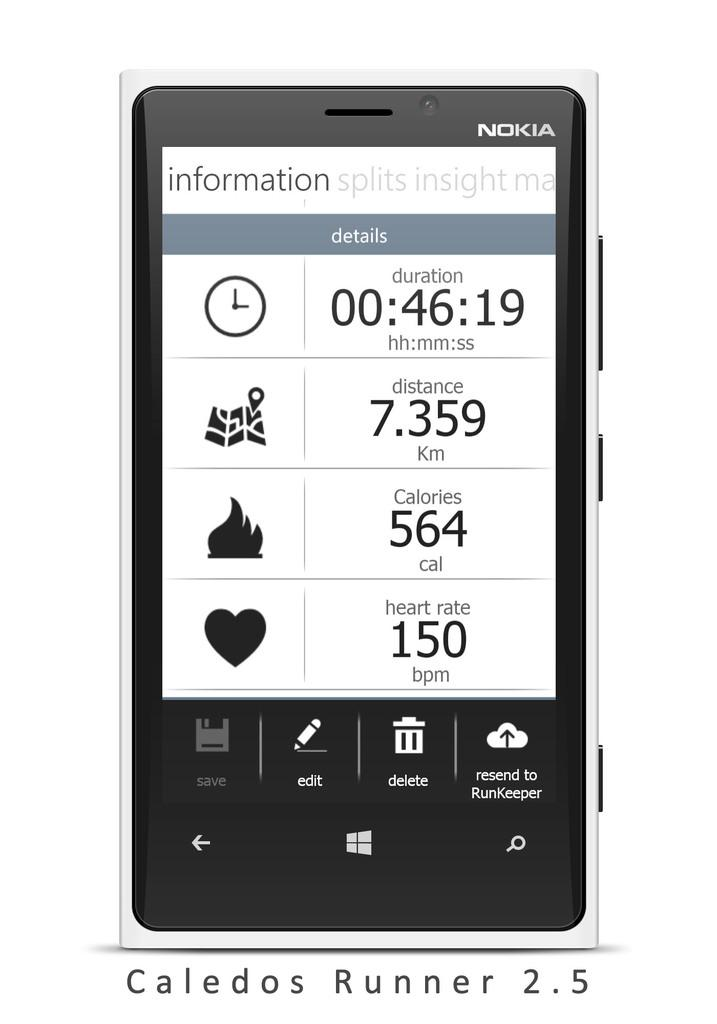<image>
Describe the image concisely. A Nokia Caledos Runner 2.5 phone shows a health display with calories burned as 564 